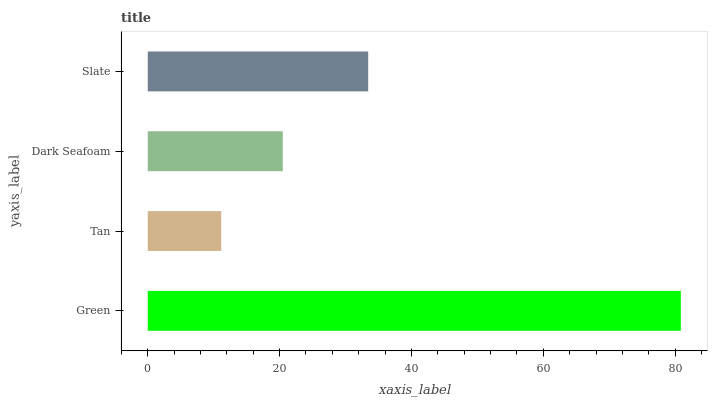Is Tan the minimum?
Answer yes or no. Yes. Is Green the maximum?
Answer yes or no. Yes. Is Dark Seafoam the minimum?
Answer yes or no. No. Is Dark Seafoam the maximum?
Answer yes or no. No. Is Dark Seafoam greater than Tan?
Answer yes or no. Yes. Is Tan less than Dark Seafoam?
Answer yes or no. Yes. Is Tan greater than Dark Seafoam?
Answer yes or no. No. Is Dark Seafoam less than Tan?
Answer yes or no. No. Is Slate the high median?
Answer yes or no. Yes. Is Dark Seafoam the low median?
Answer yes or no. Yes. Is Dark Seafoam the high median?
Answer yes or no. No. Is Slate the low median?
Answer yes or no. No. 